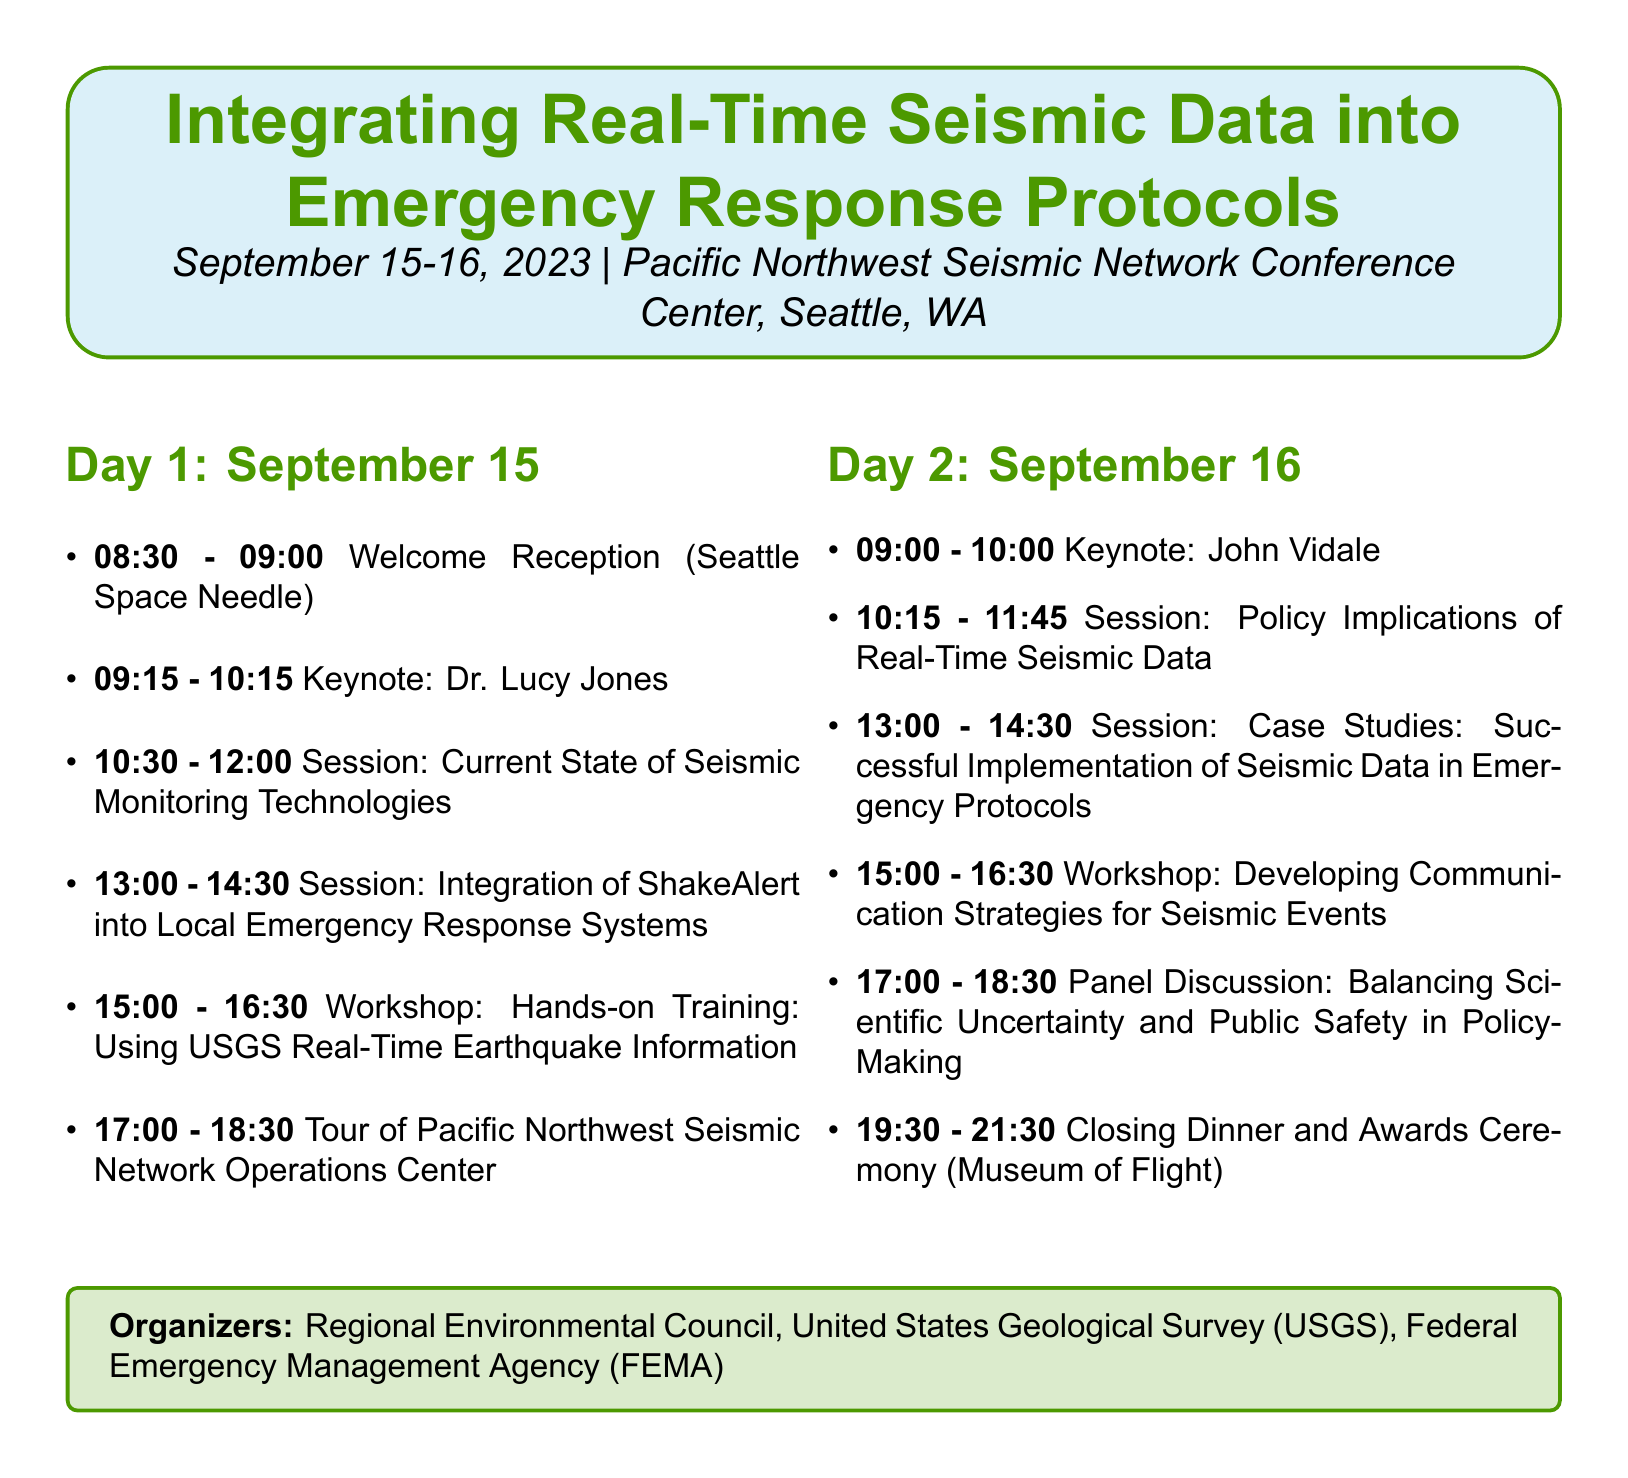what is the title of the workshop? The title of the workshop is stated at the beginning of the agenda document.
Answer: Integrating Real-Time Seismic Data into Emergency Response Protocols who is the keynote speaker on September 16? This information is provided in the schedule of the document, indicating the keynote sessions.
Answer: John Vidale what is the venue for the workshop? The venue is mentioned at the start of the document and can be found in the title section.
Answer: Pacific Northwest Seismic Network Conference Center, Seattle, WA how many sessions are scheduled for the second day? The number of sessions is counted based on the items listed under Day 2.
Answer: Four who is facilitating the workshop on communication strategies? The facilitator's name is listed under the workshops section of the agenda.
Answer: Dr. Wendy Bohon what is the topic of Dr. Lucy Jones' keynote speech? The topic of her speech is specified next to her name in the keynote speakers list.
Answer: The Future of Earthquake Early Warning Systems which organization is involved as a co-organizer along with the Regional Environmental Council? The document lists the organizers at the end, revealing the collaborating organizations.
Answer: United States Geological Survey (USGS) where will the closing dinner take place? The location of the closing dinner is specified in the networking events section.
Answer: Museum of Flight, Seattle 